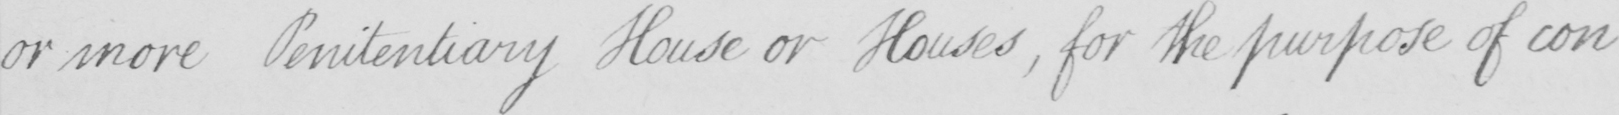Please transcribe the handwritten text in this image. or more Penitentiary House or Houses  , for the purpose of con- 